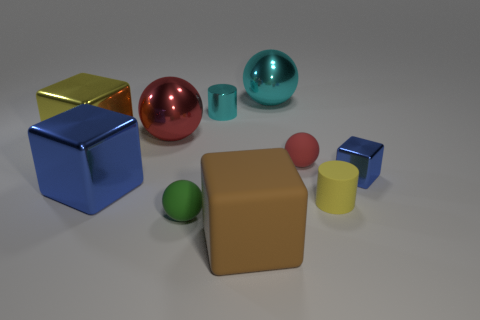What number of cyan objects are either rubber blocks or tiny objects?
Give a very brief answer. 1. Is the color of the shiny sphere that is to the right of the red shiny sphere the same as the cylinder behind the tiny blue shiny cube?
Offer a terse response. Yes. There is a tiny object that is behind the red object in front of the metal sphere that is in front of the cyan ball; what is its color?
Keep it short and to the point. Cyan. There is a blue object on the left side of the small blue object; are there any tiny balls in front of it?
Make the answer very short. Yes. There is a tiny cyan object on the right side of the yellow metal thing; is it the same shape as the brown object?
Your answer should be very brief. No. Are there any other things that are the same shape as the tiny red matte object?
Offer a very short reply. Yes. How many blocks are tiny green matte things or small rubber objects?
Keep it short and to the point. 0. How many small red rubber spheres are there?
Give a very brief answer. 1. What is the size of the blue object to the left of the large ball that is behind the small cyan shiny object?
Your response must be concise. Large. What number of other things are the same size as the green rubber ball?
Your answer should be very brief. 4. 